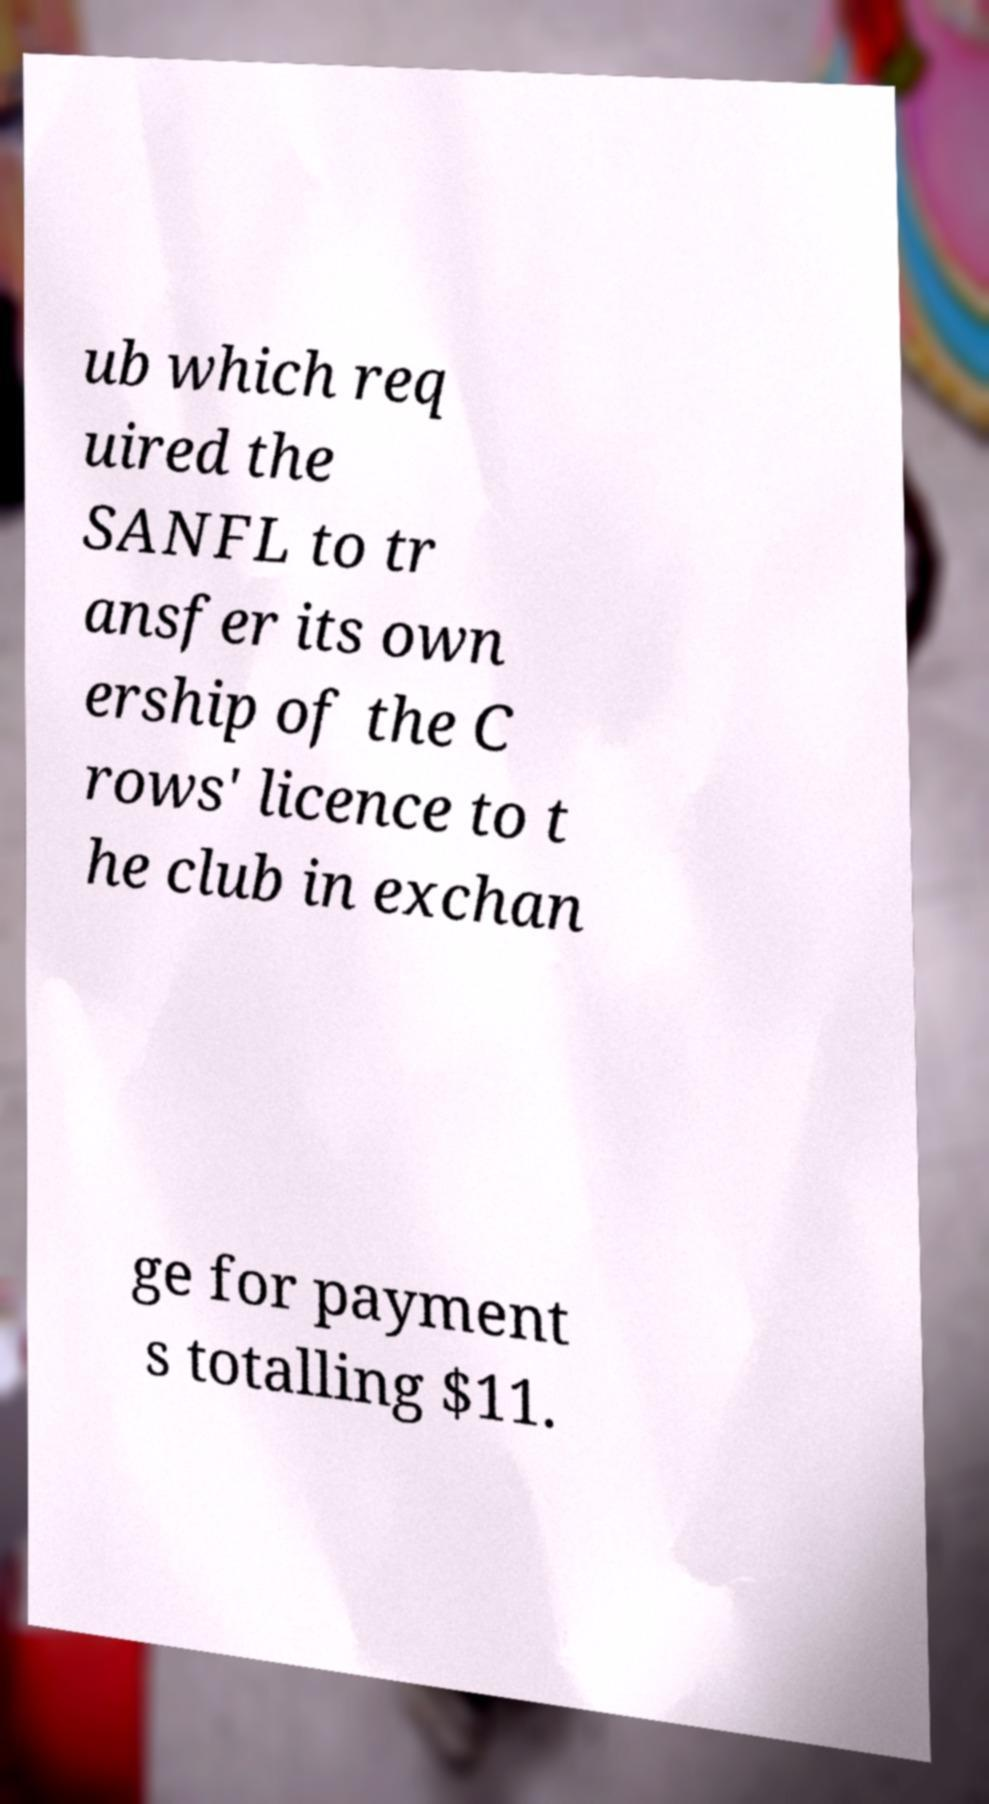Could you extract and type out the text from this image? ub which req uired the SANFL to tr ansfer its own ership of the C rows' licence to t he club in exchan ge for payment s totalling $11. 